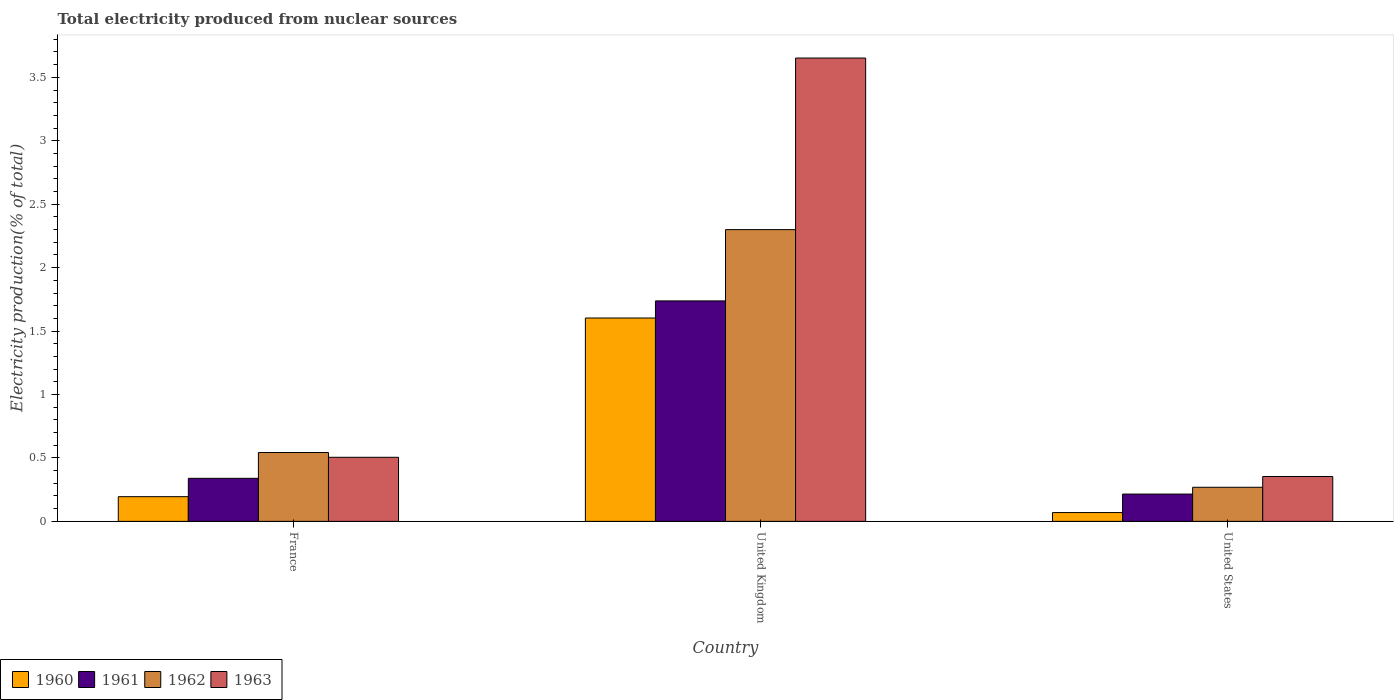How many different coloured bars are there?
Your answer should be very brief. 4. Are the number of bars per tick equal to the number of legend labels?
Offer a terse response. Yes. How many bars are there on the 1st tick from the left?
Give a very brief answer. 4. In how many cases, is the number of bars for a given country not equal to the number of legend labels?
Give a very brief answer. 0. What is the total electricity produced in 1962 in United States?
Ensure brevity in your answer.  0.27. Across all countries, what is the maximum total electricity produced in 1963?
Make the answer very short. 3.65. Across all countries, what is the minimum total electricity produced in 1963?
Your response must be concise. 0.35. In which country was the total electricity produced in 1960 maximum?
Make the answer very short. United Kingdom. What is the total total electricity produced in 1963 in the graph?
Give a very brief answer. 4.51. What is the difference between the total electricity produced in 1961 in France and that in United Kingdom?
Offer a terse response. -1.4. What is the difference between the total electricity produced in 1962 in France and the total electricity produced in 1963 in United States?
Your answer should be compact. 0.19. What is the average total electricity produced in 1961 per country?
Your response must be concise. 0.76. What is the difference between the total electricity produced of/in 1960 and total electricity produced of/in 1962 in United States?
Your response must be concise. -0.2. In how many countries, is the total electricity produced in 1963 greater than 1.1 %?
Your answer should be very brief. 1. What is the ratio of the total electricity produced in 1962 in United Kingdom to that in United States?
Offer a very short reply. 8.56. Is the total electricity produced in 1962 in United Kingdom less than that in United States?
Make the answer very short. No. What is the difference between the highest and the second highest total electricity produced in 1961?
Make the answer very short. -1.4. What is the difference between the highest and the lowest total electricity produced in 1961?
Your response must be concise. 1.52. Is it the case that in every country, the sum of the total electricity produced in 1963 and total electricity produced in 1962 is greater than the sum of total electricity produced in 1961 and total electricity produced in 1960?
Offer a very short reply. No. What does the 2nd bar from the left in France represents?
Make the answer very short. 1961. How many bars are there?
Make the answer very short. 12. Are all the bars in the graph horizontal?
Provide a short and direct response. No. How many countries are there in the graph?
Your answer should be very brief. 3. What is the difference between two consecutive major ticks on the Y-axis?
Your answer should be compact. 0.5. Does the graph contain any zero values?
Your answer should be compact. No. Does the graph contain grids?
Your answer should be compact. No. Where does the legend appear in the graph?
Ensure brevity in your answer.  Bottom left. What is the title of the graph?
Offer a very short reply. Total electricity produced from nuclear sources. What is the label or title of the Y-axis?
Keep it short and to the point. Electricity production(% of total). What is the Electricity production(% of total) in 1960 in France?
Offer a very short reply. 0.19. What is the Electricity production(% of total) in 1961 in France?
Ensure brevity in your answer.  0.34. What is the Electricity production(% of total) in 1962 in France?
Offer a very short reply. 0.54. What is the Electricity production(% of total) in 1963 in France?
Offer a terse response. 0.51. What is the Electricity production(% of total) of 1960 in United Kingdom?
Provide a short and direct response. 1.6. What is the Electricity production(% of total) of 1961 in United Kingdom?
Give a very brief answer. 1.74. What is the Electricity production(% of total) of 1962 in United Kingdom?
Your answer should be very brief. 2.3. What is the Electricity production(% of total) in 1963 in United Kingdom?
Keep it short and to the point. 3.65. What is the Electricity production(% of total) in 1960 in United States?
Your answer should be very brief. 0.07. What is the Electricity production(% of total) in 1961 in United States?
Provide a succinct answer. 0.22. What is the Electricity production(% of total) of 1962 in United States?
Offer a very short reply. 0.27. What is the Electricity production(% of total) in 1963 in United States?
Keep it short and to the point. 0.35. Across all countries, what is the maximum Electricity production(% of total) of 1960?
Give a very brief answer. 1.6. Across all countries, what is the maximum Electricity production(% of total) in 1961?
Make the answer very short. 1.74. Across all countries, what is the maximum Electricity production(% of total) in 1962?
Your answer should be very brief. 2.3. Across all countries, what is the maximum Electricity production(% of total) of 1963?
Your answer should be very brief. 3.65. Across all countries, what is the minimum Electricity production(% of total) of 1960?
Your response must be concise. 0.07. Across all countries, what is the minimum Electricity production(% of total) in 1961?
Provide a short and direct response. 0.22. Across all countries, what is the minimum Electricity production(% of total) of 1962?
Keep it short and to the point. 0.27. Across all countries, what is the minimum Electricity production(% of total) in 1963?
Keep it short and to the point. 0.35. What is the total Electricity production(% of total) in 1960 in the graph?
Provide a short and direct response. 1.87. What is the total Electricity production(% of total) of 1961 in the graph?
Keep it short and to the point. 2.29. What is the total Electricity production(% of total) of 1962 in the graph?
Give a very brief answer. 3.11. What is the total Electricity production(% of total) of 1963 in the graph?
Offer a terse response. 4.51. What is the difference between the Electricity production(% of total) of 1960 in France and that in United Kingdom?
Your answer should be compact. -1.41. What is the difference between the Electricity production(% of total) of 1961 in France and that in United Kingdom?
Your answer should be compact. -1.4. What is the difference between the Electricity production(% of total) of 1962 in France and that in United Kingdom?
Your response must be concise. -1.76. What is the difference between the Electricity production(% of total) in 1963 in France and that in United Kingdom?
Your answer should be very brief. -3.15. What is the difference between the Electricity production(% of total) of 1960 in France and that in United States?
Provide a short and direct response. 0.13. What is the difference between the Electricity production(% of total) of 1961 in France and that in United States?
Make the answer very short. 0.12. What is the difference between the Electricity production(% of total) in 1962 in France and that in United States?
Give a very brief answer. 0.27. What is the difference between the Electricity production(% of total) in 1963 in France and that in United States?
Make the answer very short. 0.15. What is the difference between the Electricity production(% of total) in 1960 in United Kingdom and that in United States?
Your response must be concise. 1.53. What is the difference between the Electricity production(% of total) in 1961 in United Kingdom and that in United States?
Provide a short and direct response. 1.52. What is the difference between the Electricity production(% of total) in 1962 in United Kingdom and that in United States?
Make the answer very short. 2.03. What is the difference between the Electricity production(% of total) of 1963 in United Kingdom and that in United States?
Ensure brevity in your answer.  3.3. What is the difference between the Electricity production(% of total) of 1960 in France and the Electricity production(% of total) of 1961 in United Kingdom?
Your answer should be very brief. -1.54. What is the difference between the Electricity production(% of total) in 1960 in France and the Electricity production(% of total) in 1962 in United Kingdom?
Give a very brief answer. -2.11. What is the difference between the Electricity production(% of total) of 1960 in France and the Electricity production(% of total) of 1963 in United Kingdom?
Ensure brevity in your answer.  -3.46. What is the difference between the Electricity production(% of total) in 1961 in France and the Electricity production(% of total) in 1962 in United Kingdom?
Offer a very short reply. -1.96. What is the difference between the Electricity production(% of total) in 1961 in France and the Electricity production(% of total) in 1963 in United Kingdom?
Your answer should be very brief. -3.31. What is the difference between the Electricity production(% of total) of 1962 in France and the Electricity production(% of total) of 1963 in United Kingdom?
Your response must be concise. -3.11. What is the difference between the Electricity production(% of total) in 1960 in France and the Electricity production(% of total) in 1961 in United States?
Make the answer very short. -0.02. What is the difference between the Electricity production(% of total) of 1960 in France and the Electricity production(% of total) of 1962 in United States?
Ensure brevity in your answer.  -0.07. What is the difference between the Electricity production(% of total) of 1960 in France and the Electricity production(% of total) of 1963 in United States?
Give a very brief answer. -0.16. What is the difference between the Electricity production(% of total) of 1961 in France and the Electricity production(% of total) of 1962 in United States?
Offer a terse response. 0.07. What is the difference between the Electricity production(% of total) of 1961 in France and the Electricity production(% of total) of 1963 in United States?
Keep it short and to the point. -0.01. What is the difference between the Electricity production(% of total) in 1962 in France and the Electricity production(% of total) in 1963 in United States?
Your answer should be compact. 0.19. What is the difference between the Electricity production(% of total) of 1960 in United Kingdom and the Electricity production(% of total) of 1961 in United States?
Keep it short and to the point. 1.39. What is the difference between the Electricity production(% of total) of 1960 in United Kingdom and the Electricity production(% of total) of 1962 in United States?
Make the answer very short. 1.33. What is the difference between the Electricity production(% of total) of 1960 in United Kingdom and the Electricity production(% of total) of 1963 in United States?
Give a very brief answer. 1.25. What is the difference between the Electricity production(% of total) of 1961 in United Kingdom and the Electricity production(% of total) of 1962 in United States?
Give a very brief answer. 1.47. What is the difference between the Electricity production(% of total) in 1961 in United Kingdom and the Electricity production(% of total) in 1963 in United States?
Provide a short and direct response. 1.38. What is the difference between the Electricity production(% of total) in 1962 in United Kingdom and the Electricity production(% of total) in 1963 in United States?
Your response must be concise. 1.95. What is the average Electricity production(% of total) in 1960 per country?
Your answer should be very brief. 0.62. What is the average Electricity production(% of total) in 1961 per country?
Your answer should be very brief. 0.76. What is the average Electricity production(% of total) of 1962 per country?
Make the answer very short. 1.04. What is the average Electricity production(% of total) of 1963 per country?
Provide a succinct answer. 1.5. What is the difference between the Electricity production(% of total) of 1960 and Electricity production(% of total) of 1961 in France?
Offer a very short reply. -0.14. What is the difference between the Electricity production(% of total) of 1960 and Electricity production(% of total) of 1962 in France?
Your answer should be very brief. -0.35. What is the difference between the Electricity production(% of total) in 1960 and Electricity production(% of total) in 1963 in France?
Provide a short and direct response. -0.31. What is the difference between the Electricity production(% of total) in 1961 and Electricity production(% of total) in 1962 in France?
Make the answer very short. -0.2. What is the difference between the Electricity production(% of total) of 1961 and Electricity production(% of total) of 1963 in France?
Ensure brevity in your answer.  -0.17. What is the difference between the Electricity production(% of total) of 1962 and Electricity production(% of total) of 1963 in France?
Ensure brevity in your answer.  0.04. What is the difference between the Electricity production(% of total) in 1960 and Electricity production(% of total) in 1961 in United Kingdom?
Your response must be concise. -0.13. What is the difference between the Electricity production(% of total) of 1960 and Electricity production(% of total) of 1962 in United Kingdom?
Offer a terse response. -0.7. What is the difference between the Electricity production(% of total) of 1960 and Electricity production(% of total) of 1963 in United Kingdom?
Provide a short and direct response. -2.05. What is the difference between the Electricity production(% of total) in 1961 and Electricity production(% of total) in 1962 in United Kingdom?
Make the answer very short. -0.56. What is the difference between the Electricity production(% of total) of 1961 and Electricity production(% of total) of 1963 in United Kingdom?
Your answer should be compact. -1.91. What is the difference between the Electricity production(% of total) in 1962 and Electricity production(% of total) in 1963 in United Kingdom?
Ensure brevity in your answer.  -1.35. What is the difference between the Electricity production(% of total) of 1960 and Electricity production(% of total) of 1961 in United States?
Offer a very short reply. -0.15. What is the difference between the Electricity production(% of total) of 1960 and Electricity production(% of total) of 1962 in United States?
Make the answer very short. -0.2. What is the difference between the Electricity production(% of total) in 1960 and Electricity production(% of total) in 1963 in United States?
Your response must be concise. -0.28. What is the difference between the Electricity production(% of total) of 1961 and Electricity production(% of total) of 1962 in United States?
Your answer should be very brief. -0.05. What is the difference between the Electricity production(% of total) of 1961 and Electricity production(% of total) of 1963 in United States?
Keep it short and to the point. -0.14. What is the difference between the Electricity production(% of total) in 1962 and Electricity production(% of total) in 1963 in United States?
Make the answer very short. -0.09. What is the ratio of the Electricity production(% of total) in 1960 in France to that in United Kingdom?
Your answer should be compact. 0.12. What is the ratio of the Electricity production(% of total) of 1961 in France to that in United Kingdom?
Provide a short and direct response. 0.2. What is the ratio of the Electricity production(% of total) of 1962 in France to that in United Kingdom?
Your answer should be compact. 0.24. What is the ratio of the Electricity production(% of total) in 1963 in France to that in United Kingdom?
Offer a very short reply. 0.14. What is the ratio of the Electricity production(% of total) of 1960 in France to that in United States?
Provide a succinct answer. 2.81. What is the ratio of the Electricity production(% of total) of 1961 in France to that in United States?
Your answer should be compact. 1.58. What is the ratio of the Electricity production(% of total) of 1962 in France to that in United States?
Offer a terse response. 2.02. What is the ratio of the Electricity production(% of total) of 1963 in France to that in United States?
Give a very brief answer. 1.43. What is the ratio of the Electricity production(% of total) in 1960 in United Kingdom to that in United States?
Keep it short and to the point. 23.14. What is the ratio of the Electricity production(% of total) in 1961 in United Kingdom to that in United States?
Offer a terse response. 8.08. What is the ratio of the Electricity production(% of total) of 1962 in United Kingdom to that in United States?
Provide a short and direct response. 8.56. What is the ratio of the Electricity production(% of total) of 1963 in United Kingdom to that in United States?
Your response must be concise. 10.32. What is the difference between the highest and the second highest Electricity production(% of total) of 1960?
Offer a very short reply. 1.41. What is the difference between the highest and the second highest Electricity production(% of total) of 1961?
Your answer should be compact. 1.4. What is the difference between the highest and the second highest Electricity production(% of total) in 1962?
Give a very brief answer. 1.76. What is the difference between the highest and the second highest Electricity production(% of total) of 1963?
Give a very brief answer. 3.15. What is the difference between the highest and the lowest Electricity production(% of total) of 1960?
Your answer should be compact. 1.53. What is the difference between the highest and the lowest Electricity production(% of total) of 1961?
Provide a short and direct response. 1.52. What is the difference between the highest and the lowest Electricity production(% of total) of 1962?
Offer a very short reply. 2.03. What is the difference between the highest and the lowest Electricity production(% of total) of 1963?
Provide a succinct answer. 3.3. 